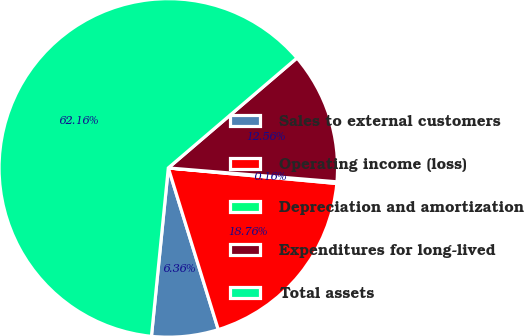Convert chart to OTSL. <chart><loc_0><loc_0><loc_500><loc_500><pie_chart><fcel>Sales to external customers<fcel>Operating income (loss)<fcel>Depreciation and amortization<fcel>Expenditures for long-lived<fcel>Total assets<nl><fcel>6.36%<fcel>18.76%<fcel>0.16%<fcel>12.56%<fcel>62.15%<nl></chart> 